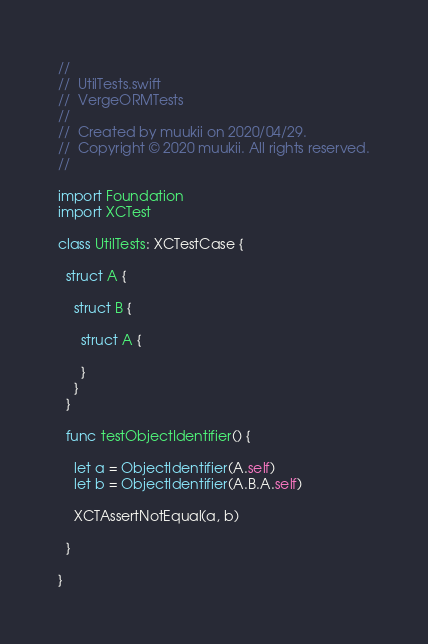Convert code to text. <code><loc_0><loc_0><loc_500><loc_500><_Swift_>//
//  UtilTests.swift
//  VergeORMTests
//
//  Created by muukii on 2020/04/29.
//  Copyright © 2020 muukii. All rights reserved.
//

import Foundation
import XCTest

class UtilTests: XCTestCase {
  
  struct A {
    
    struct B {
      
      struct A {
        
      }
    }
  }
  
  func testObjectIdentifier() {
                    
    let a = ObjectIdentifier(A.self)
    let b = ObjectIdentifier(A.B.A.self)
    
    XCTAssertNotEqual(a, b)
        
  }
    
}
</code> 